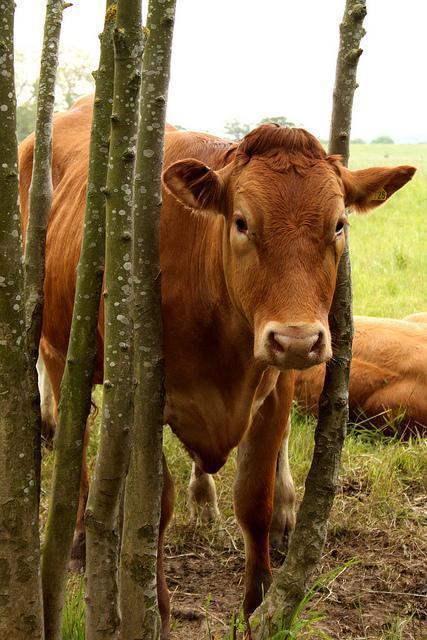How many cows can you see?
Give a very brief answer. 2. How many people are in the picture?
Give a very brief answer. 0. 